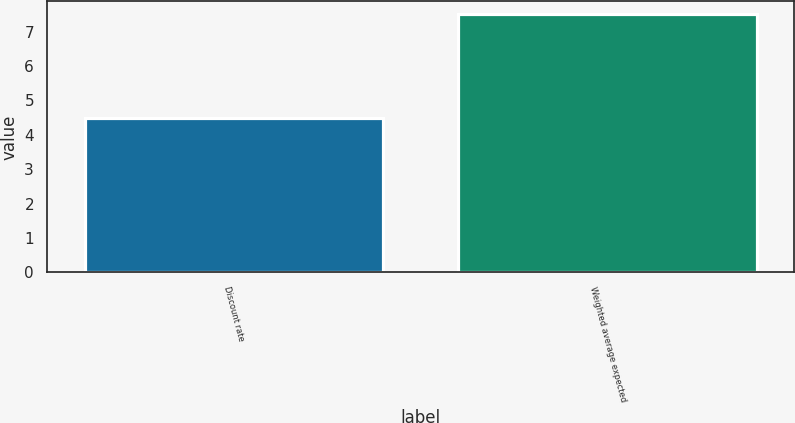Convert chart to OTSL. <chart><loc_0><loc_0><loc_500><loc_500><bar_chart><fcel>Discount rate<fcel>Weighted average expected<nl><fcel>4.5<fcel>7.5<nl></chart> 